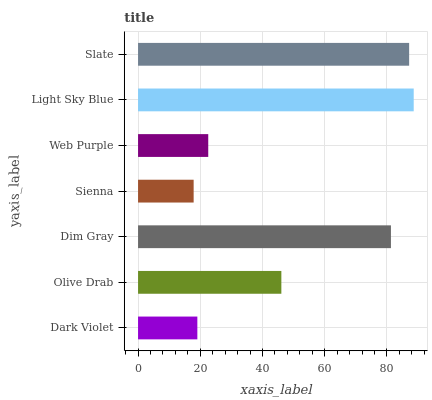Is Sienna the minimum?
Answer yes or no. Yes. Is Light Sky Blue the maximum?
Answer yes or no. Yes. Is Olive Drab the minimum?
Answer yes or no. No. Is Olive Drab the maximum?
Answer yes or no. No. Is Olive Drab greater than Dark Violet?
Answer yes or no. Yes. Is Dark Violet less than Olive Drab?
Answer yes or no. Yes. Is Dark Violet greater than Olive Drab?
Answer yes or no. No. Is Olive Drab less than Dark Violet?
Answer yes or no. No. Is Olive Drab the high median?
Answer yes or no. Yes. Is Olive Drab the low median?
Answer yes or no. Yes. Is Web Purple the high median?
Answer yes or no. No. Is Sienna the low median?
Answer yes or no. No. 